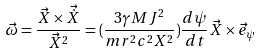Convert formula to latex. <formula><loc_0><loc_0><loc_500><loc_500>\vec { \omega } = \frac { \vec { X } \times \vec { \dot { X } } } { \vec { X } ^ { 2 } } = ( \frac { 3 \gamma M J ^ { 2 } } { m r ^ { 2 } c ^ { 2 } X ^ { 2 } } ) \frac { d \psi } { d t } \vec { X } \times \vec { e } _ { \psi }</formula> 